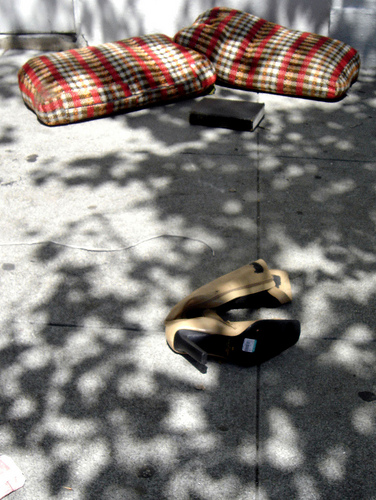<image>
Is there a pillow behind the book? Yes. From this viewpoint, the pillow is positioned behind the book, with the book partially or fully occluding the pillow. Is there a boot next to the sidewalk? No. The boot is not positioned next to the sidewalk. They are located in different areas of the scene. 